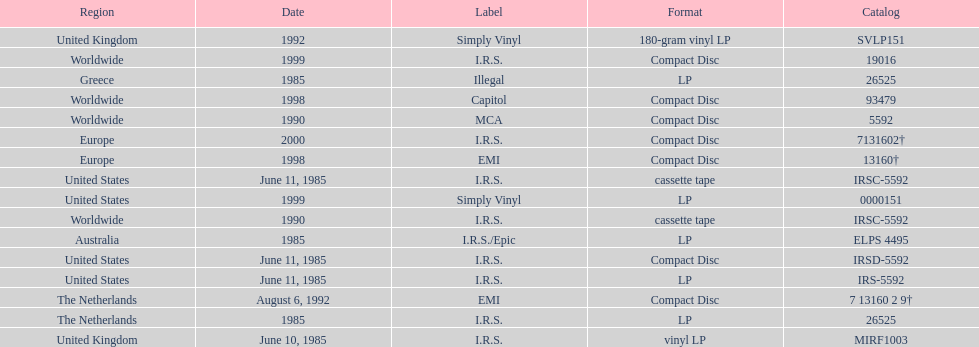What is the greatest consecutive amount of releases in lp format? 3. 